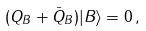<formula> <loc_0><loc_0><loc_500><loc_500>( Q _ { B } + \bar { Q } _ { B } ) | B \rangle = 0 \, ,</formula> 